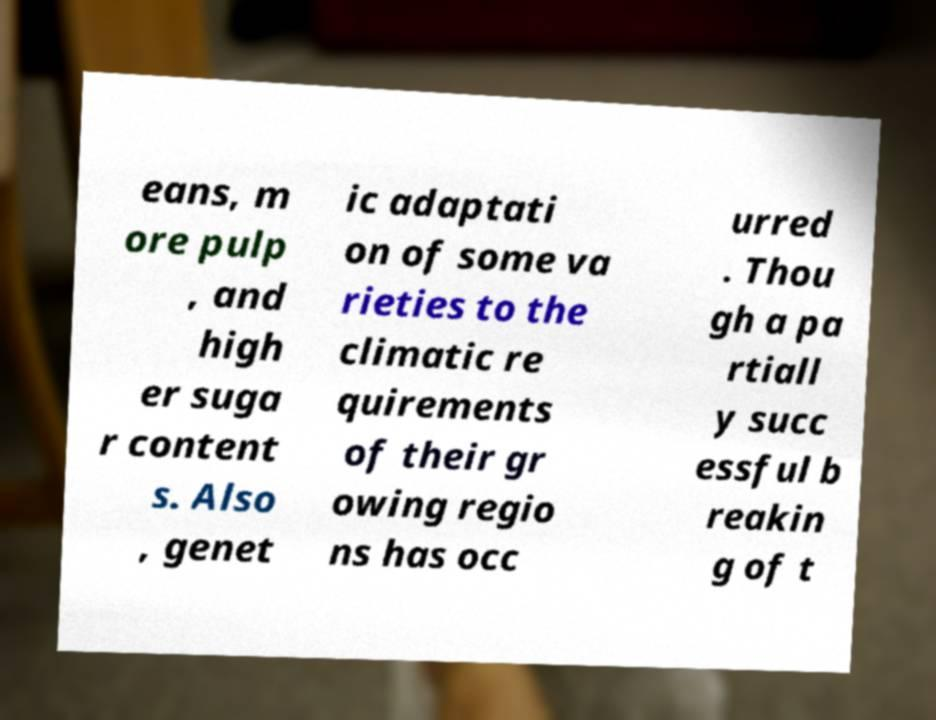Could you assist in decoding the text presented in this image and type it out clearly? eans, m ore pulp , and high er suga r content s. Also , genet ic adaptati on of some va rieties to the climatic re quirements of their gr owing regio ns has occ urred . Thou gh a pa rtiall y succ essful b reakin g of t 